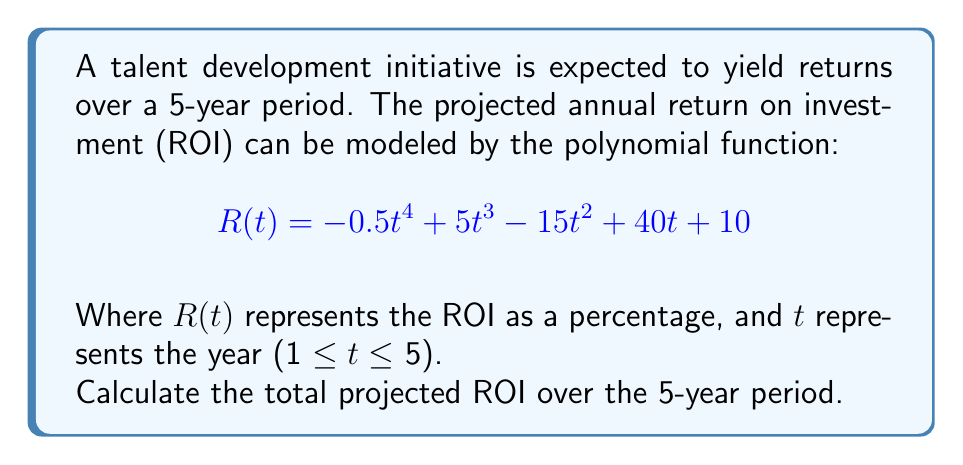Provide a solution to this math problem. To solve this problem, we need to follow these steps:

1) The total ROI over the 5-year period is the sum of the annual ROIs for each year.

2) We need to calculate $R(t)$ for $t = 1, 2, 3, 4,$ and $5$, then sum these values.

3) Let's calculate each year's ROI:

   For $t = 1$:
   $R(1) = -0.5(1)^4 + 5(1)^3 - 15(1)^2 + 40(1) + 10 = -0.5 + 5 - 15 + 40 + 10 = 39.5\%$

   For $t = 2$:
   $R(2) = -0.5(2)^4 + 5(2)^3 - 15(2)^2 + 40(2) + 10 = -8 + 40 - 60 + 80 + 10 = 62\%$

   For $t = 3$:
   $R(3) = -0.5(3)^4 + 5(3)^3 - 15(3)^2 + 40(3) + 10 = -40.5 + 135 - 135 + 120 + 10 = 89.5\%$

   For $t = 4$:
   $R(4) = -0.5(4)^4 + 5(4)^3 - 15(4)^2 + 40(4) + 10 = -128 + 320 - 240 + 160 + 10 = 122\%$

   For $t = 5$:
   $R(5) = -0.5(5)^4 + 5(5)^3 - 15(5)^2 + 40(5) + 10 = -312.5 + 625 - 375 + 200 + 10 = 147.5\%$

4) Now, we sum these values:

   Total ROI = $39.5\% + 62\% + 89.5\% + 122\% + 147.5\% = 460.5\%$

Therefore, the total projected ROI over the 5-year period is 460.5%.
Answer: 460.5% 